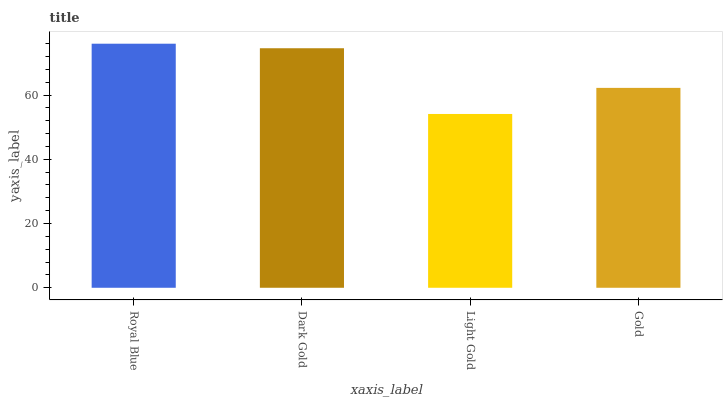Is Light Gold the minimum?
Answer yes or no. Yes. Is Royal Blue the maximum?
Answer yes or no. Yes. Is Dark Gold the minimum?
Answer yes or no. No. Is Dark Gold the maximum?
Answer yes or no. No. Is Royal Blue greater than Dark Gold?
Answer yes or no. Yes. Is Dark Gold less than Royal Blue?
Answer yes or no. Yes. Is Dark Gold greater than Royal Blue?
Answer yes or no. No. Is Royal Blue less than Dark Gold?
Answer yes or no. No. Is Dark Gold the high median?
Answer yes or no. Yes. Is Gold the low median?
Answer yes or no. Yes. Is Royal Blue the high median?
Answer yes or no. No. Is Light Gold the low median?
Answer yes or no. No. 